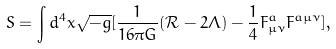<formula> <loc_0><loc_0><loc_500><loc_500>S = \int d ^ { 4 } x \sqrt { - g } [ \frac { 1 } { 1 6 \pi G } ( \mathcal { R } - 2 \Lambda ) - \frac { 1 } { 4 } F _ { \mu \nu } ^ { a } F ^ { a \mu \nu } ] ,</formula> 